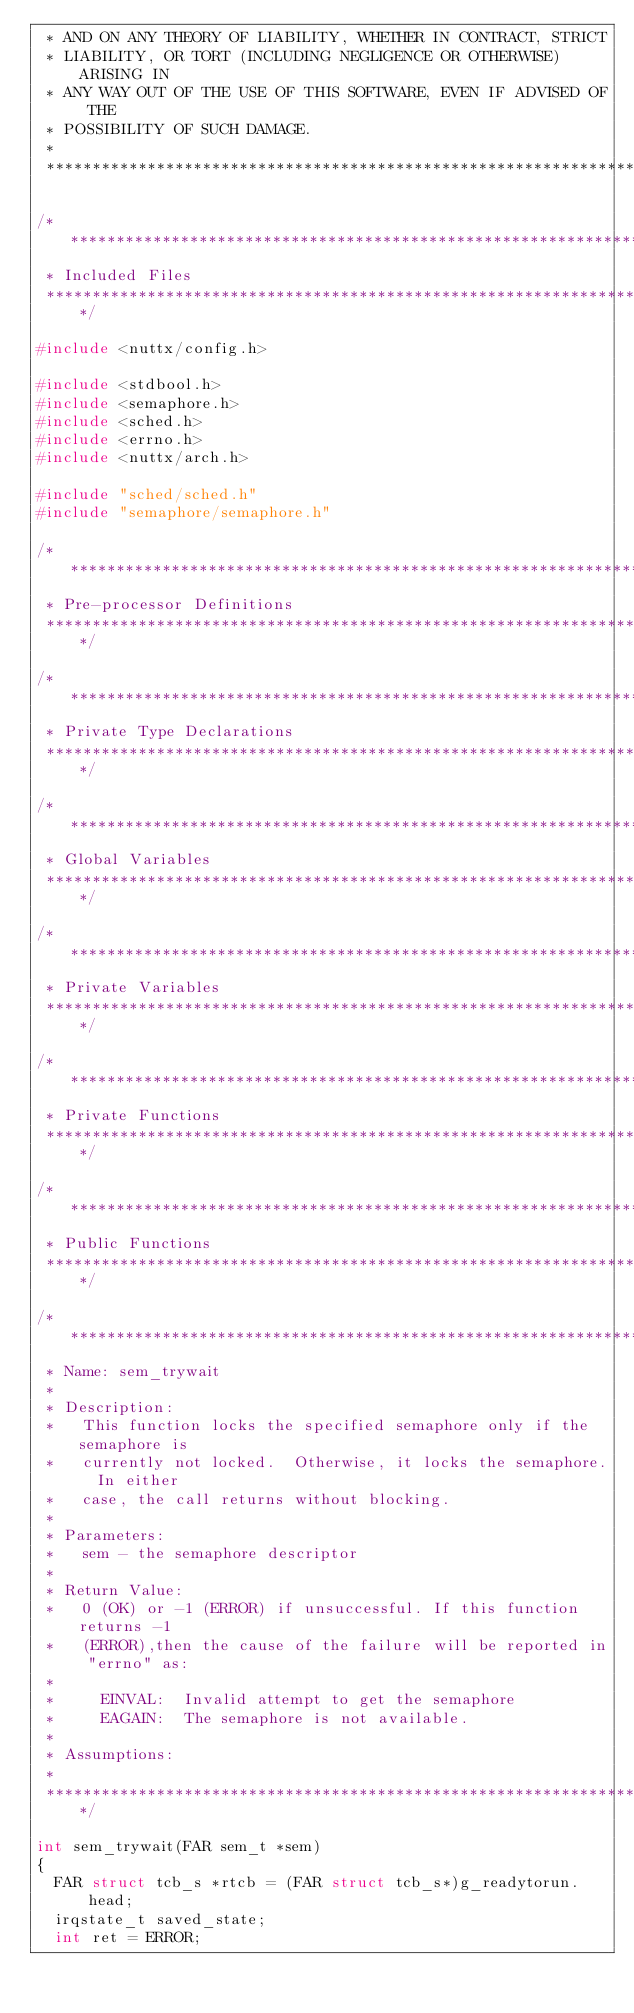Convert code to text. <code><loc_0><loc_0><loc_500><loc_500><_C_> * AND ON ANY THEORY OF LIABILITY, WHETHER IN CONTRACT, STRICT
 * LIABILITY, OR TORT (INCLUDING NEGLIGENCE OR OTHERWISE) ARISING IN
 * ANY WAY OUT OF THE USE OF THIS SOFTWARE, EVEN IF ADVISED OF THE
 * POSSIBILITY OF SUCH DAMAGE.
 *
 ****************************************************************************/

/****************************************************************************
 * Included Files
 ****************************************************************************/

#include <nuttx/config.h>

#include <stdbool.h>
#include <semaphore.h>
#include <sched.h>
#include <errno.h>
#include <nuttx/arch.h>

#include "sched/sched.h"
#include "semaphore/semaphore.h"

/****************************************************************************
 * Pre-processor Definitions
 ****************************************************************************/

/****************************************************************************
 * Private Type Declarations
 ****************************************************************************/

/****************************************************************************
 * Global Variables
 ****************************************************************************/

/****************************************************************************
 * Private Variables
 ****************************************************************************/

/****************************************************************************
 * Private Functions
 ****************************************************************************/

/****************************************************************************
 * Public Functions
 ****************************************************************************/

/****************************************************************************
 * Name: sem_trywait
 *
 * Description:
 *   This function locks the specified semaphore only if the semaphore is
 *   currently not locked.  Otherwise, it locks the semaphore.  In either
 *   case, the call returns without blocking.
 *
 * Parameters:
 *   sem - the semaphore descriptor
 *
 * Return Value:
 *   0 (OK) or -1 (ERROR) if unsuccessful. If this function returns -1
 *   (ERROR),then the cause of the failure will be reported in "errno" as:
 *
 *     EINVAL:  Invalid attempt to get the semaphore
 *     EAGAIN:  The semaphore is not available.
 *
 * Assumptions:
 *
 ****************************************************************************/

int sem_trywait(FAR sem_t *sem)
{
  FAR struct tcb_s *rtcb = (FAR struct tcb_s*)g_readytorun.head;
  irqstate_t saved_state;
  int ret = ERROR;
</code> 